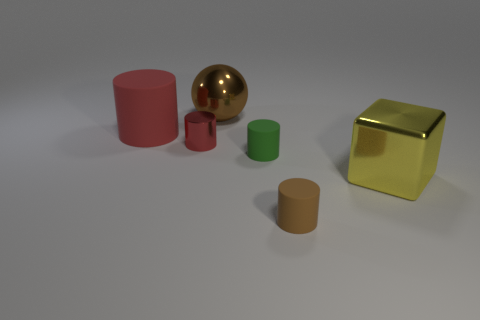Subtract all big cylinders. How many cylinders are left? 3 Add 1 big matte objects. How many objects exist? 7 Subtract all red cylinders. How many cylinders are left? 2 Subtract 1 cylinders. How many cylinders are left? 3 Subtract all yellow blocks. How many red cylinders are left? 2 Subtract all yellow cylinders. Subtract all green balls. How many cylinders are left? 4 Subtract all brown matte cylinders. Subtract all matte things. How many objects are left? 2 Add 2 small shiny things. How many small shiny things are left? 3 Add 5 gray matte blocks. How many gray matte blocks exist? 5 Subtract 1 red cylinders. How many objects are left? 5 